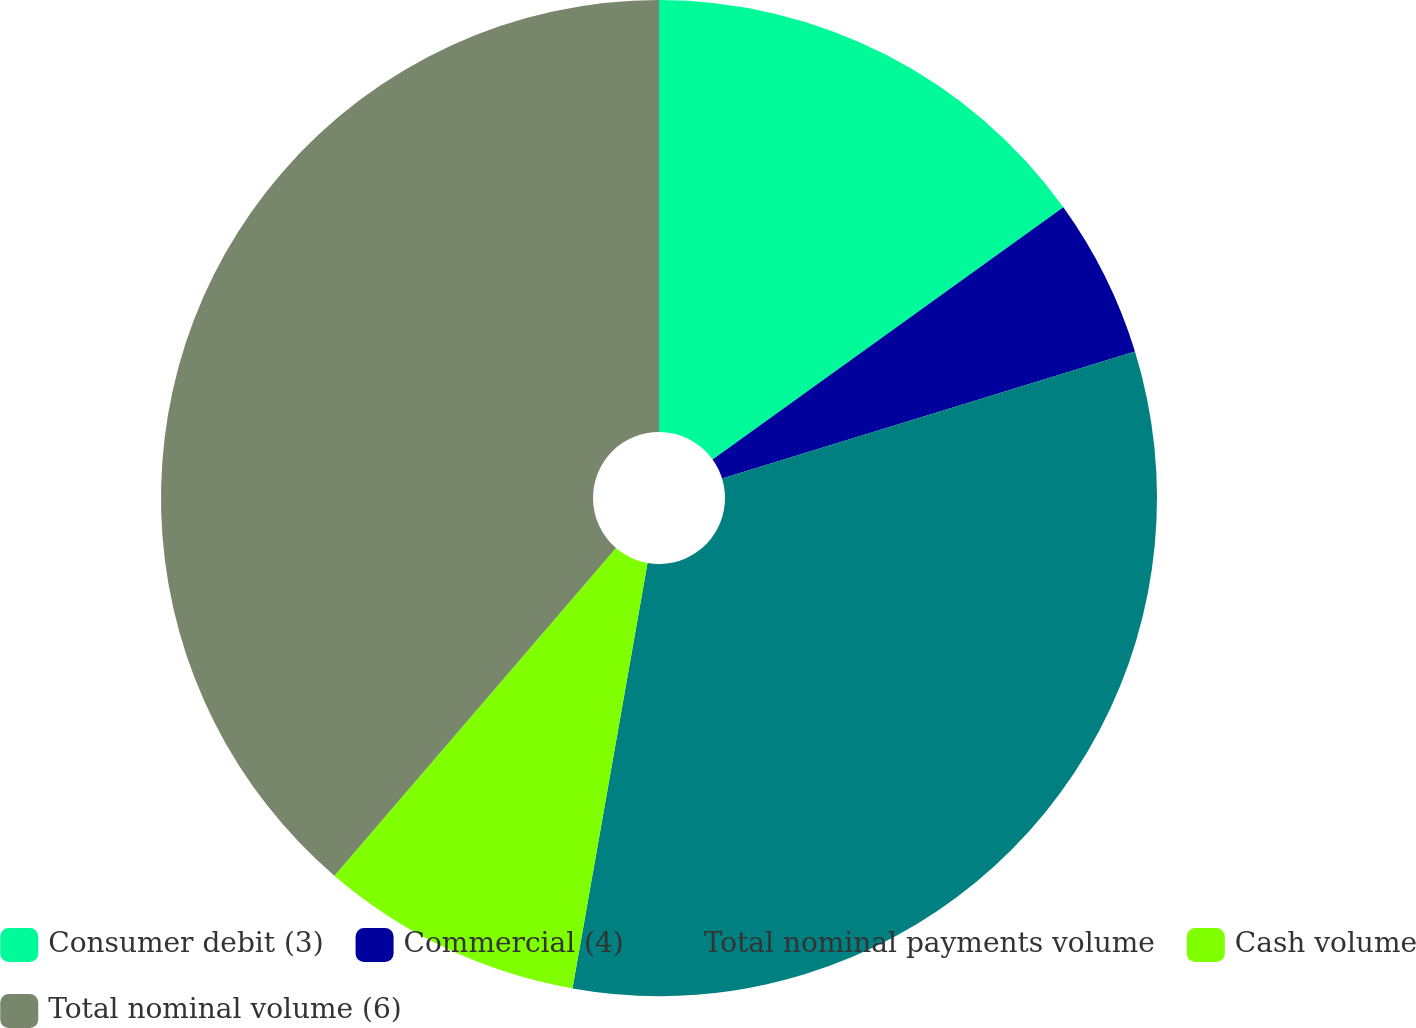Convert chart. <chart><loc_0><loc_0><loc_500><loc_500><pie_chart><fcel>Consumer debit (3)<fcel>Commercial (4)<fcel>Total nominal payments volume<fcel>Cash volume<fcel>Total nominal volume (6)<nl><fcel>15.08%<fcel>5.17%<fcel>32.53%<fcel>8.52%<fcel>38.7%<nl></chart> 